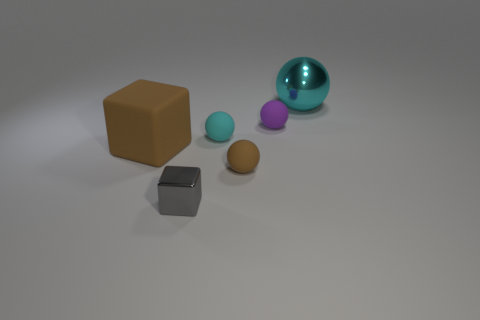What size is the brown block? The brown block appears to be of a medium size relative to the other objects within the image, which include smaller spheres and a larger transparent blue sphere. 